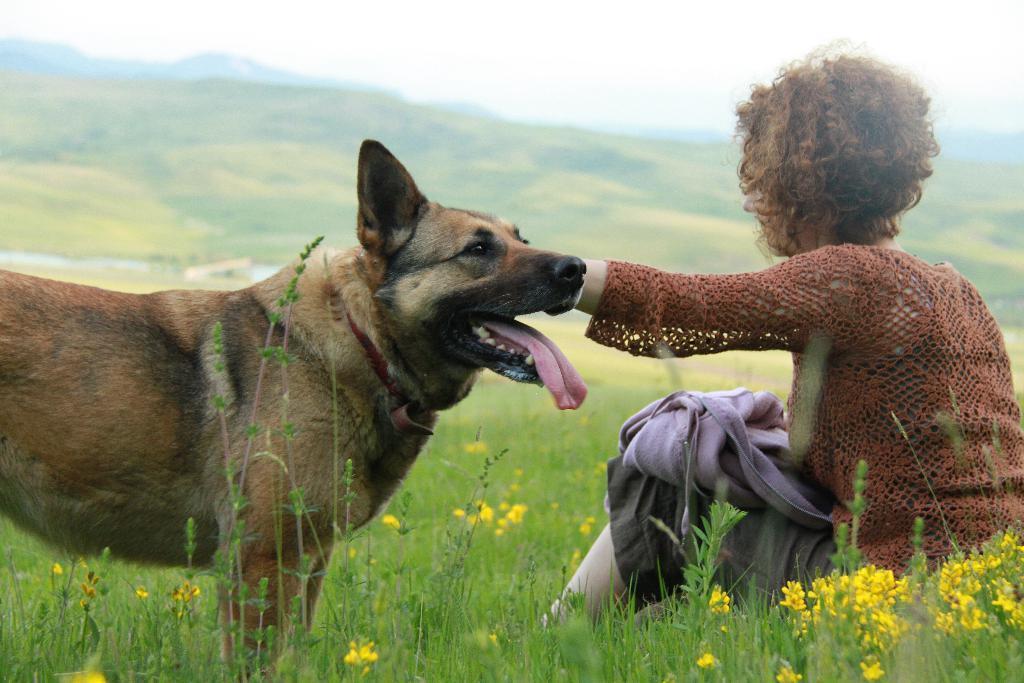Could you give a brief overview of what you see in this image? In the middle of the image a person is sitting on the grass. Bottom left side of the image there is a dog. Top left side of the image there is a hill. Top right side of the image there is a sky and clouds. 